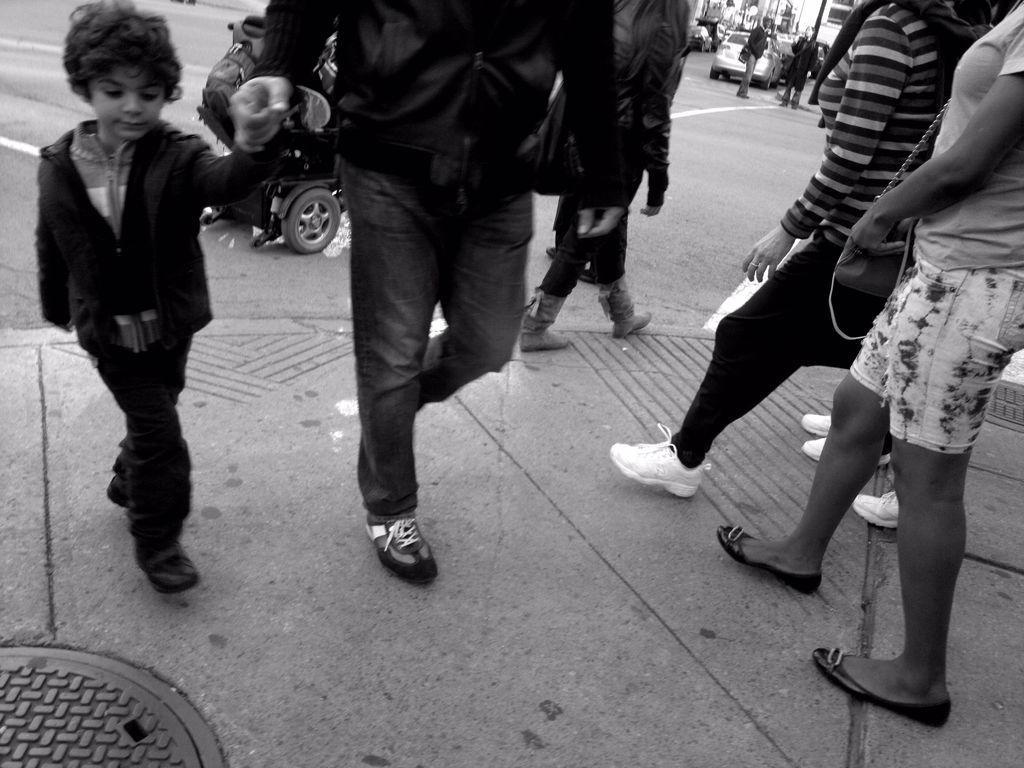Describe this image in one or two sentences. As we can see in the image there are few people here and there and on road there is a car. 